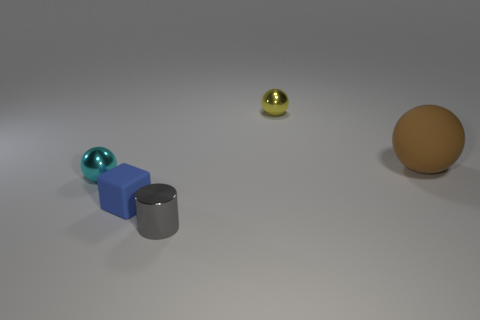Add 5 cyan balls. How many objects exist? 10 Subtract all blocks. How many objects are left? 4 Subtract 0 cyan cubes. How many objects are left? 5 Subtract all green matte blocks. Subtract all yellow shiny spheres. How many objects are left? 4 Add 2 tiny yellow objects. How many tiny yellow objects are left? 3 Add 1 small metal things. How many small metal things exist? 4 